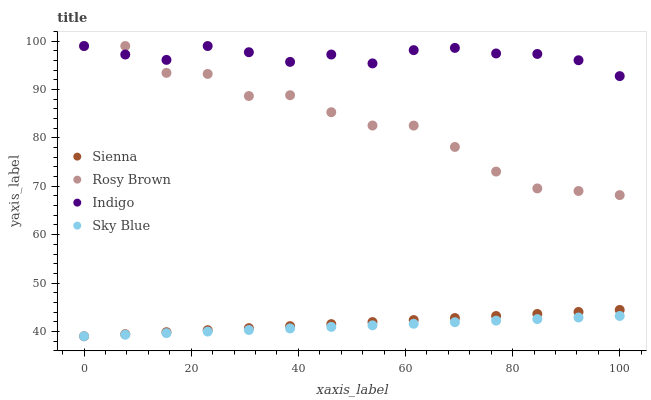Does Sky Blue have the minimum area under the curve?
Answer yes or no. Yes. Does Indigo have the maximum area under the curve?
Answer yes or no. Yes. Does Rosy Brown have the minimum area under the curve?
Answer yes or no. No. Does Rosy Brown have the maximum area under the curve?
Answer yes or no. No. Is Sienna the smoothest?
Answer yes or no. Yes. Is Rosy Brown the roughest?
Answer yes or no. Yes. Is Sky Blue the smoothest?
Answer yes or no. No. Is Sky Blue the roughest?
Answer yes or no. No. Does Sienna have the lowest value?
Answer yes or no. Yes. Does Rosy Brown have the lowest value?
Answer yes or no. No. Does Indigo have the highest value?
Answer yes or no. Yes. Does Sky Blue have the highest value?
Answer yes or no. No. Is Sienna less than Rosy Brown?
Answer yes or no. Yes. Is Rosy Brown greater than Sky Blue?
Answer yes or no. Yes. Does Indigo intersect Rosy Brown?
Answer yes or no. Yes. Is Indigo less than Rosy Brown?
Answer yes or no. No. Is Indigo greater than Rosy Brown?
Answer yes or no. No. Does Sienna intersect Rosy Brown?
Answer yes or no. No. 